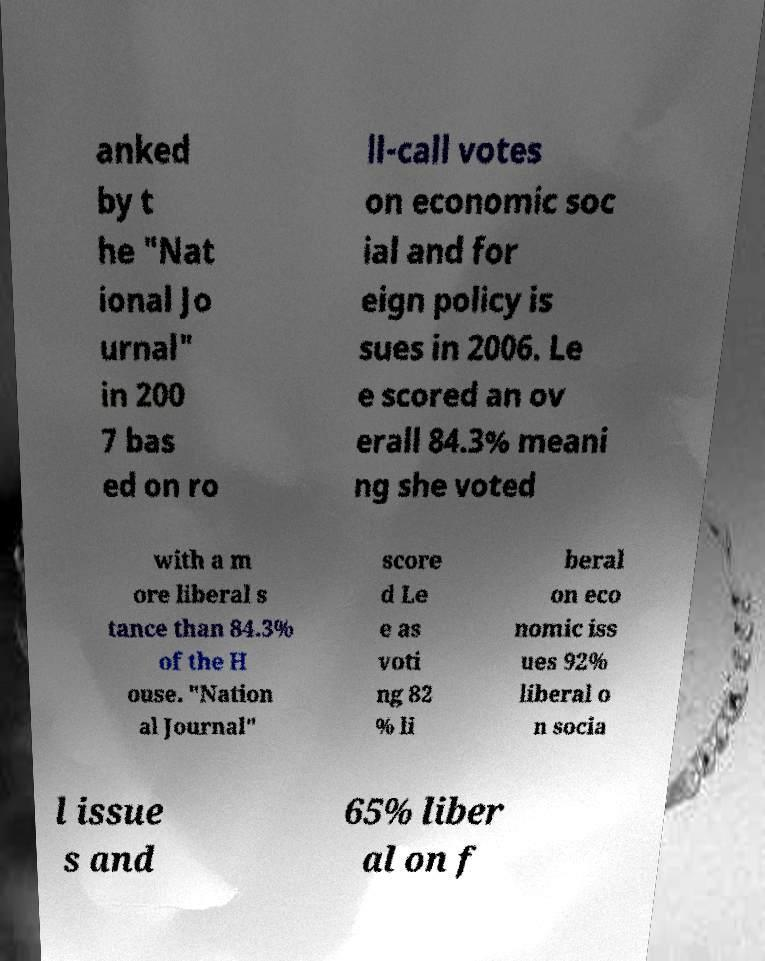What messages or text are displayed in this image? I need them in a readable, typed format. anked by t he "Nat ional Jo urnal" in 200 7 bas ed on ro ll-call votes on economic soc ial and for eign policy is sues in 2006. Le e scored an ov erall 84.3% meani ng she voted with a m ore liberal s tance than 84.3% of the H ouse. "Nation al Journal" score d Le e as voti ng 82 % li beral on eco nomic iss ues 92% liberal o n socia l issue s and 65% liber al on f 